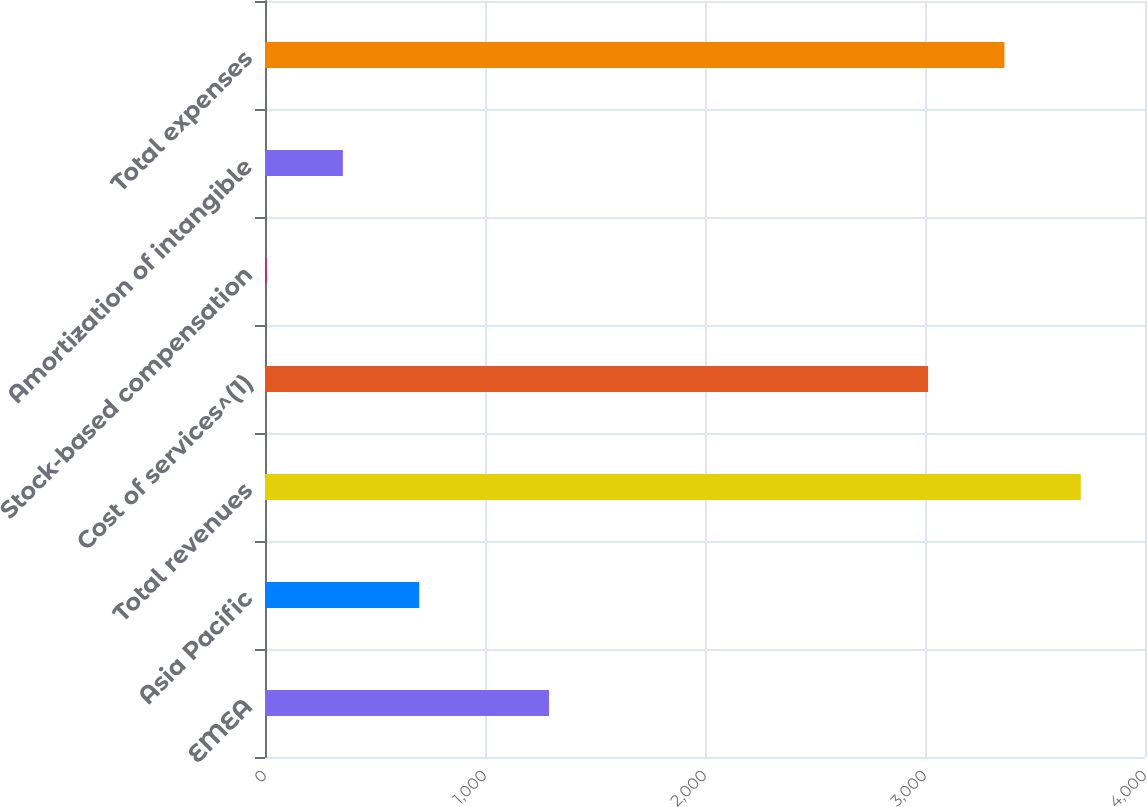<chart> <loc_0><loc_0><loc_500><loc_500><bar_chart><fcel>EMEA<fcel>Asia Pacific<fcel>Total revenues<fcel>Cost of services^(1)<fcel>Stock-based compensation<fcel>Amortization of intangible<fcel>Total expenses<nl><fcel>1291<fcel>701<fcel>3708<fcel>3014<fcel>7<fcel>354<fcel>3361<nl></chart> 